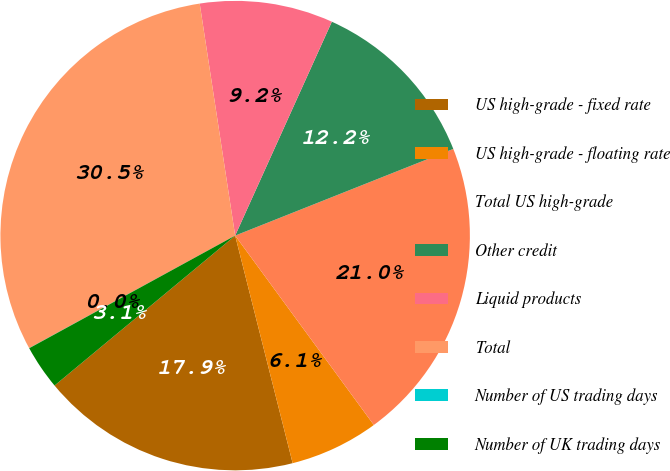<chart> <loc_0><loc_0><loc_500><loc_500><pie_chart><fcel>US high-grade - fixed rate<fcel>US high-grade - floating rate<fcel>Total US high-grade<fcel>Other credit<fcel>Liquid products<fcel>Total<fcel>Number of US trading days<fcel>Number of UK trading days<nl><fcel>17.91%<fcel>6.12%<fcel>20.96%<fcel>12.22%<fcel>9.17%<fcel>30.54%<fcel>0.01%<fcel>3.06%<nl></chart> 